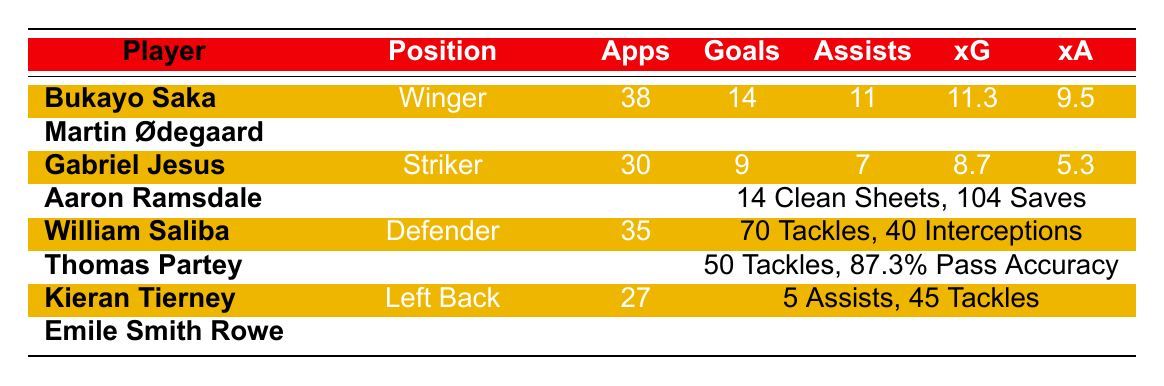What is the total number of goals scored by Bukayo Saka and Martin Ødegaard combined? Bukayo Saka scored 14 goals and Martin Ødegaard scored 15 goals. Adding these together gives 14 + 15 = 29 goals.
Answer: 29 Which player has the highest average rating in the table? The average ratings are listed for three players: Aaron Ramsdale (7.2), William Saliba (7.5), and Kieran Tierney (7.0). The highest among these is William Saliba with an average rating of 7.5.
Answer: 7.5 Did Gabriel Jesus have more assists than goals? Gabriel Jesus scored 9 goals and provided 7 assists. Since 7 is less than 9, it is true that he had more goals than assists.
Answer: No What is the average number of successful dribbles for the players listed? The successful dribbles for Saka (76), Ødegaard (40), Jesus (34), Partey (25), Tierney (not provided), and Smith Rowe (35) sum to 76 + 40 + 34 + 25 + 35 = 210. There are 5 players with dribble data (excluding Tierney), so the average is 210 / 5 = 42.
Answer: 42 How many clean sheets did Aaron Ramsdale achieve this season? Aaron Ramsdale had 14 clean sheets, which is specifically listed in the table as part of his performance metrics.
Answer: 14 What is the total number of appearances made by the midfielders in the table? The midfielders in the table are Martin Ødegaard (37 apps), Thomas Partey (30 apps), Kieran Tierney (27 apps), and Emile Smith Rowe (23 apps). Adding these gives 37 + 30 + 27 + 23 = 117 appearances.
Answer: 117 Is it true that Thomas Partey had the highest pass accuracy among the listed players? Thomas Partey's pass accuracy is 87.3%. The only other player listed with pass accuracy is Aaron Ramsdale at 84.6%, which is lower than Partey's. So yes, Partey had the highest.
Answer: Yes Which player made the most key passes? The key passes are as follows: Saka (52), Ødegaard (60), Jesus (37), Tierney (24), and Smith Rowe (30). Ødegaard made the most key passes with 60.
Answer: 60 